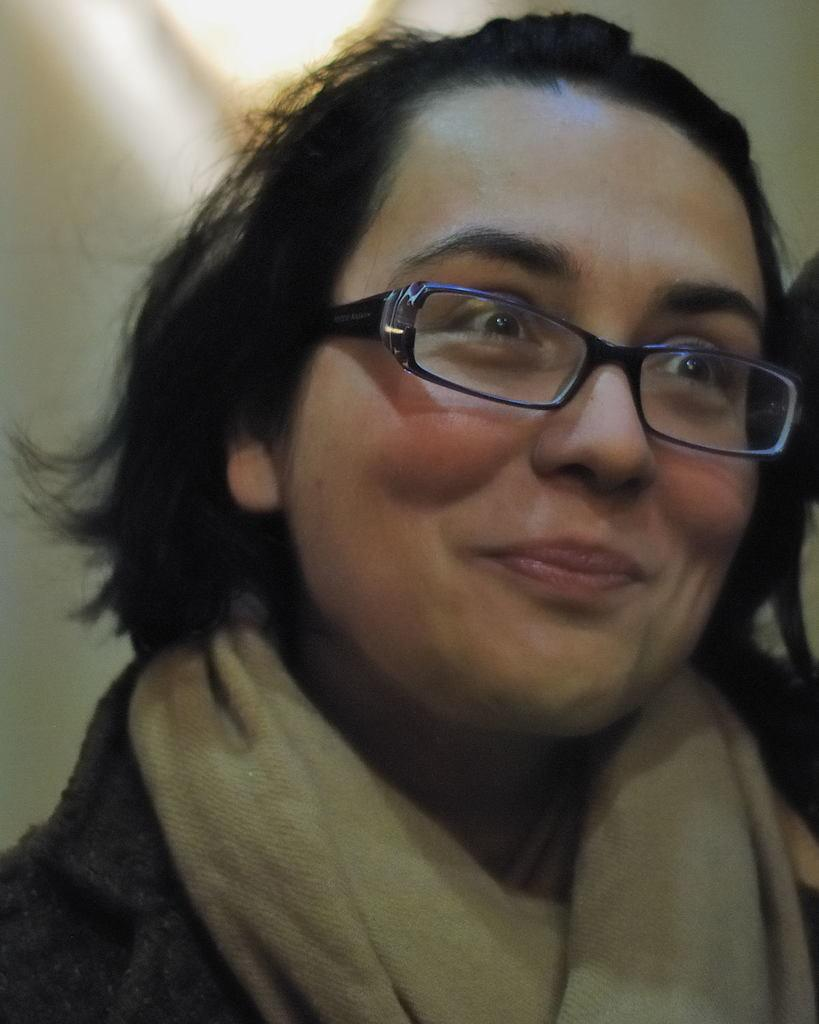Who is present in the image? There is a woman in the image. What expression does the woman have? The woman is smiling. Can you describe the background of the image? The background of the image is blurred. What type of grain can be seen on the woman's shirt in the image? There is no grain visible on the woman's shirt in the image. 